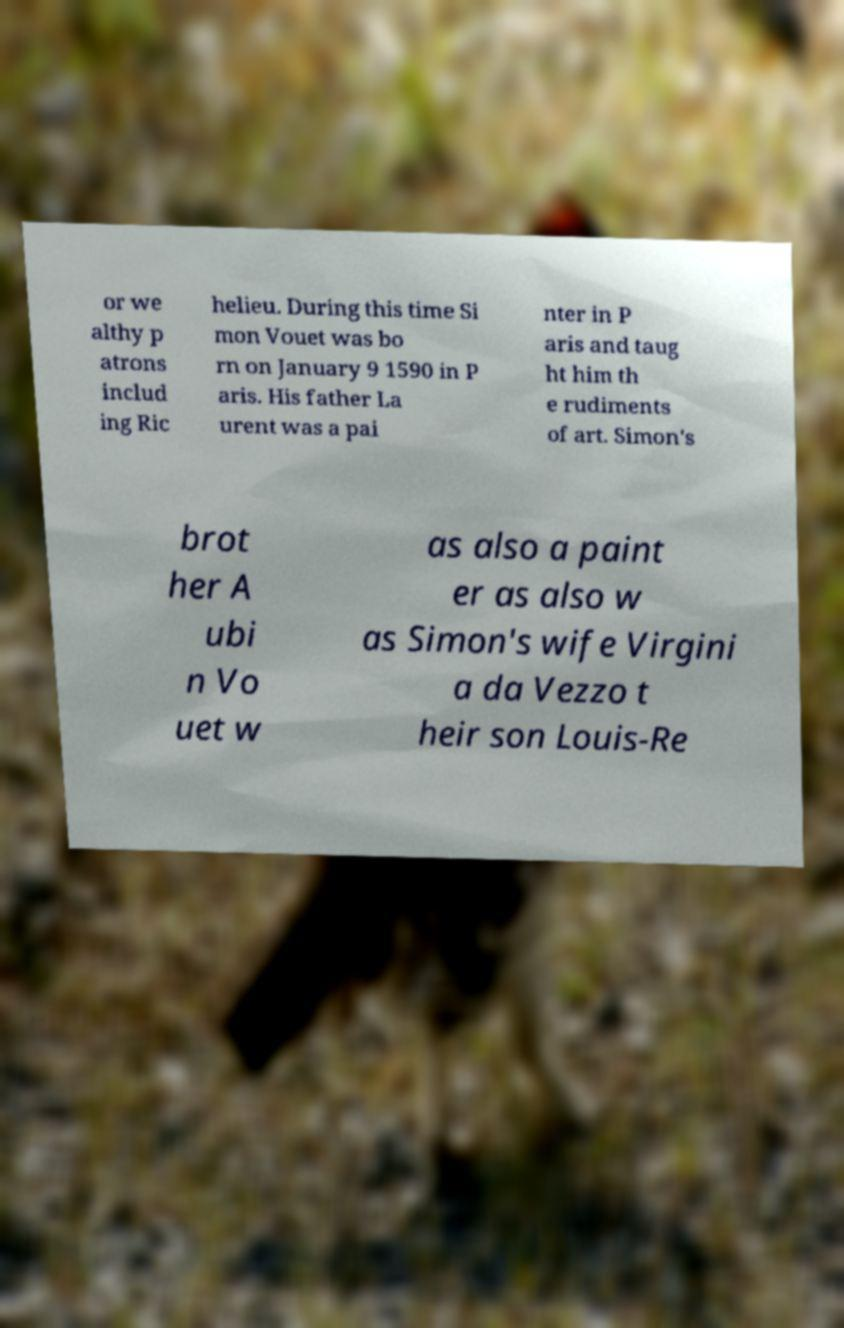Could you extract and type out the text from this image? or we althy p atrons includ ing Ric helieu. During this time Si mon Vouet was bo rn on January 9 1590 in P aris. His father La urent was a pai nter in P aris and taug ht him th e rudiments of art. Simon's brot her A ubi n Vo uet w as also a paint er as also w as Simon's wife Virgini a da Vezzo t heir son Louis-Re 